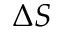Convert formula to latex. <formula><loc_0><loc_0><loc_500><loc_500>\Delta S</formula> 